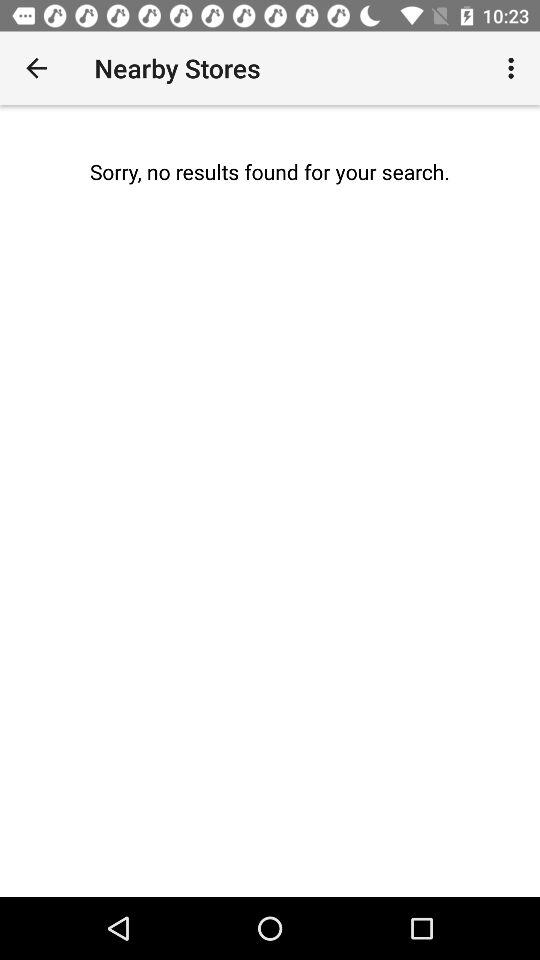Are there any nearby stores? There is no nearby store. 